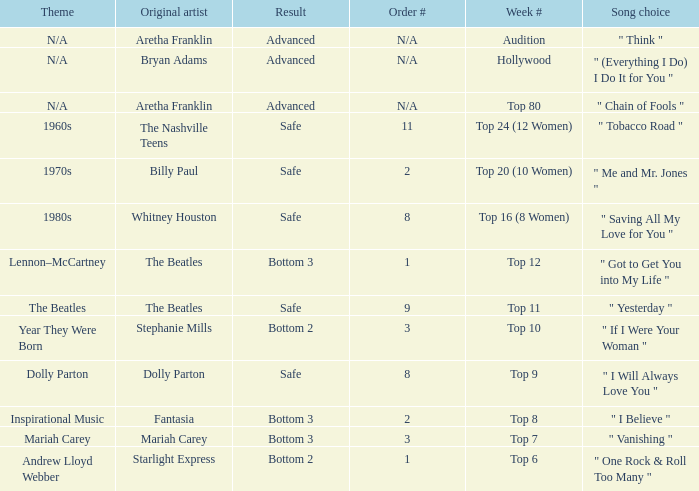Parse the table in full. {'header': ['Theme', 'Original artist', 'Result', 'Order #', 'Week #', 'Song choice'], 'rows': [['N/A', 'Aretha Franklin', 'Advanced', 'N/A', 'Audition', '" Think "'], ['N/A', 'Bryan Adams', 'Advanced', 'N/A', 'Hollywood', '" (Everything I Do) I Do It for You "'], ['N/A', 'Aretha Franklin', 'Advanced', 'N/A', 'Top 80', '" Chain of Fools "'], ['1960s', 'The Nashville Teens', 'Safe', '11', 'Top 24 (12 Women)', '" Tobacco Road "'], ['1970s', 'Billy Paul', 'Safe', '2', 'Top 20 (10 Women)', '" Me and Mr. Jones "'], ['1980s', 'Whitney Houston', 'Safe', '8', 'Top 16 (8 Women)', '" Saving All My Love for You "'], ['Lennon–McCartney', 'The Beatles', 'Bottom 3', '1', 'Top 12', '" Got to Get You into My Life "'], ['The Beatles', 'The Beatles', 'Safe', '9', 'Top 11', '" Yesterday "'], ['Year They Were Born', 'Stephanie Mills', 'Bottom 2', '3', 'Top 10', '" If I Were Your Woman "'], ['Dolly Parton', 'Dolly Parton', 'Safe', '8', 'Top 9', '" I Will Always Love You "'], ['Inspirational Music', 'Fantasia', 'Bottom 3', '2', 'Top 8', '" I Believe "'], ['Mariah Carey', 'Mariah Carey', 'Bottom 3', '3', 'Top 7', '" Vanishing "'], ['Andrew Lloyd Webber', 'Starlight Express', 'Bottom 2', '1', 'Top 6', '" One Rock & Roll Too Many "']]} What is the song selection for the week when the theme is hollywood? " (Everything I Do) I Do It for You ". 